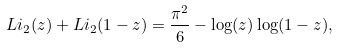Convert formula to latex. <formula><loc_0><loc_0><loc_500><loc_500>L i _ { 2 } ( z ) + L i _ { 2 } ( 1 - z ) = \frac { \pi ^ { 2 } } { 6 } - \log ( z ) \log ( 1 - z ) ,</formula> 